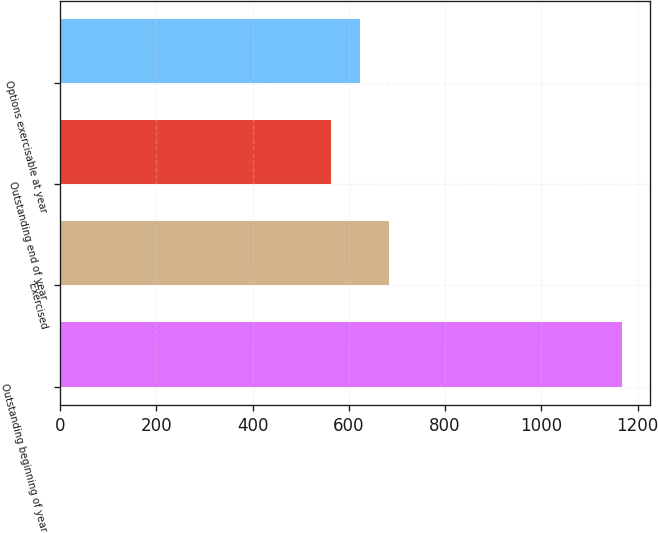Convert chart. <chart><loc_0><loc_0><loc_500><loc_500><bar_chart><fcel>Outstanding beginning of year<fcel>Exercised<fcel>Outstanding end of year<fcel>Options exercisable at year<nl><fcel>1168<fcel>684<fcel>563<fcel>623.5<nl></chart> 